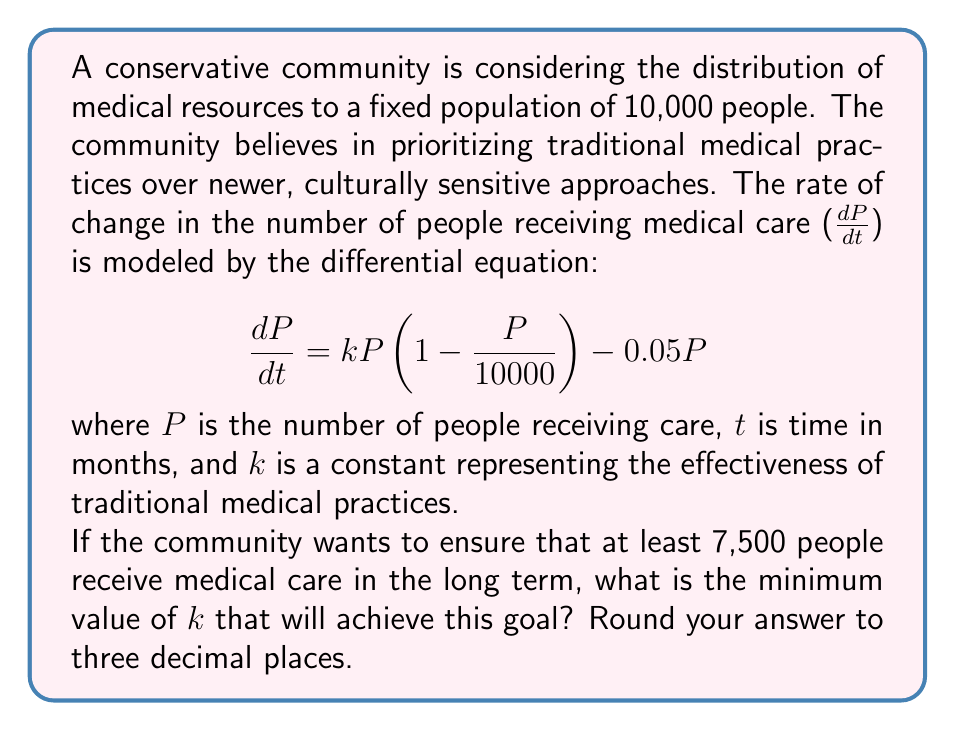Give your solution to this math problem. To solve this problem, we need to follow these steps:

1) In the long term, the population receiving care will stabilize, meaning $\frac{dP}{dt} = 0$. We can use this to find the equilibrium point.

2) Set the equation equal to zero:
   $$0 = kP(1 - \frac{P}{10000}) - 0.05P$$

3) Factor out P:
   $$0 = P(k(1 - \frac{P}{10000}) - 0.05)$$

4) For a non-zero equilibrium, solve:
   $$k(1 - \frac{P}{10000}) - 0.05 = 0$$

5) Solve for P:
   $$k - \frac{kP}{10000} = 0.05$$
   $$k - 0.05 = \frac{kP}{10000}$$
   $$P = 10000(1 - \frac{0.05}{k})$$

6) We want P to be at least 7,500, so:
   $$7500 \leq 10000(1 - \frac{0.05}{k})$$

7) Solve this inequality for k:
   $$0.75 \leq 1 - \frac{0.05}{k}$$
   $$-0.25 \geq -\frac{0.05}{k}$$
   $$0.25 \leq \frac{0.05}{k}$$
   $$k \leq \frac{0.05}{0.25} = 0.2$$

8) Since we want the minimum value of k, we take the equality:
   $$k = 0.2$$

9) Rounding to three decimal places:
   $$k = 0.200$$

Therefore, the minimum value of k to ensure at least 7,500 people receive care in the long term is 0.200.
Answer: 0.200 